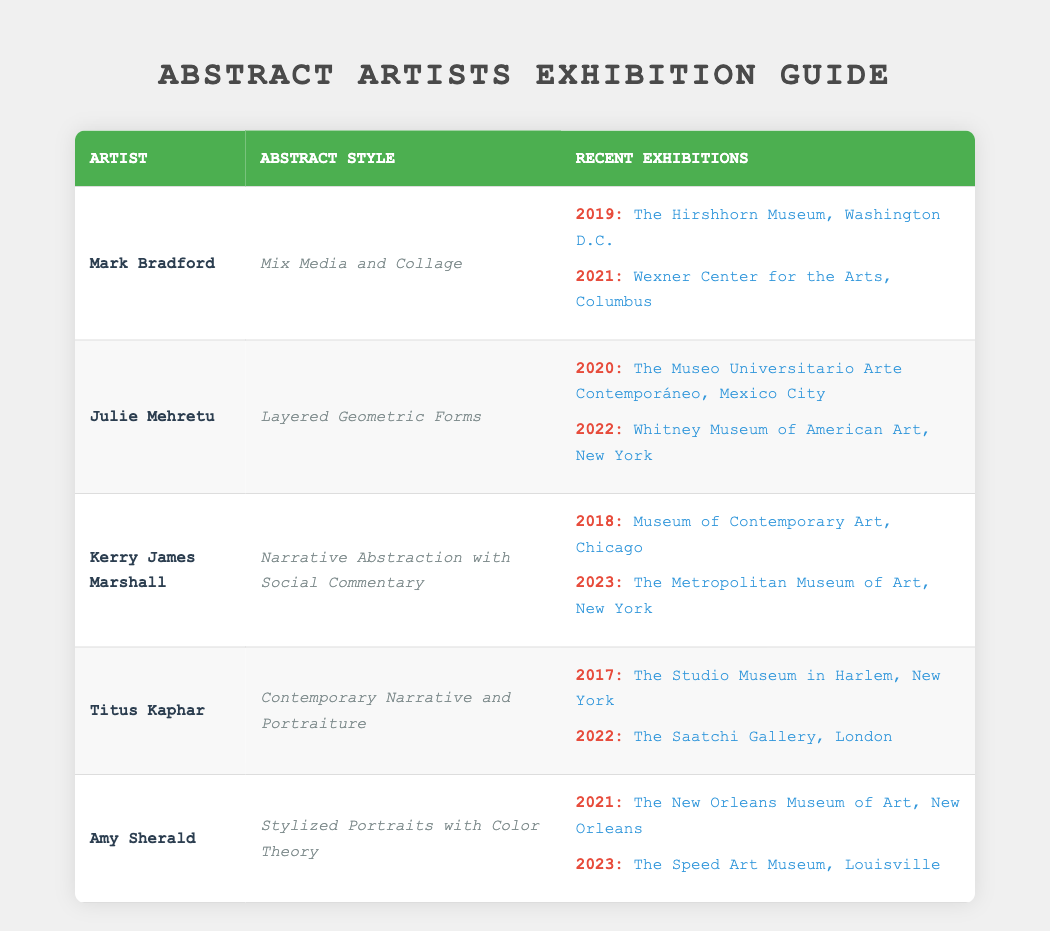What is the abstract style of Kerry James Marshall? The table shows that Kerry James Marshall's abstract style is "Narrative Abstraction with Social Commentary."
Answer: Narrative Abstraction with Social Commentary Which artist had an exhibition at the Whitney Museum of American Art and in what year? The table indicates that Julie Mehretu had an exhibition at the Whitney Museum of American Art in the year 2022.
Answer: Julie Mehretu, 2022 Are there any artists who had exhibitions in the same year as their abstract style was showcased? Yes, both Amy Sherald and Kerry James Marshall had exhibitions in 2023; Sherald at The Speed Art Museum and Marshall at The Metropolitan Museum of Art.
Answer: Yes How many exhibitions did Mark Bradford have in the last decade? According to the table, Mark Bradford had two exhibitions, one in 2019 and one in 2021, thus totaling two exhibitions in the last decade.
Answer: 2 What is the most recent exhibition location for Titus Kaphar? The table indicates that the most recent exhibition location for Titus Kaphar is "The Saatchi Gallery, London" in the year 2022.
Answer: The Saatchi Gallery, London What is the average year of exhibition for the artists listed? The years of exhibition are 2017, 2018, 2019, 2020, 2021, 2021, 2022, 2022, 2023, 2023. Summing these gives 2017 + 2018 + 2019 + 2020 + 2021 + 2021 + 2022 + 2022 + 2023 + 2023 = 20221. Dividing this by the number of exhibitions (10), we find the average year of 2022.1, which is approximately 2022 when taken as an integer.
Answer: 2022 Did any artist exhibit in London? Yes, Titus Kaphar exhibited in London at The Saatchi Gallery in 2022.
Answer: Yes Which abstract style is most associated with artists exhibiting in New York? The abstract styles associated with artists exhibiting in New York are "Layered Geometric Forms" (Julie Mehretu) and "Narrative Abstraction with Social Commentary" (Kerry James Marshall). Thus, both styles can be associated with New York.
Answer: Layered Geometric Forms, Narrative Abstraction with Social Commentary What is the difference in the number of exhibitions between Amy Sherald and Titus Kaphar? According to the table, Amy Sherald had two exhibitions (2021 and 2023), while Titus Kaphar also had two exhibitions (2017 and 2022). Thus, the difference is 2 - 2 = 0.
Answer: 0 